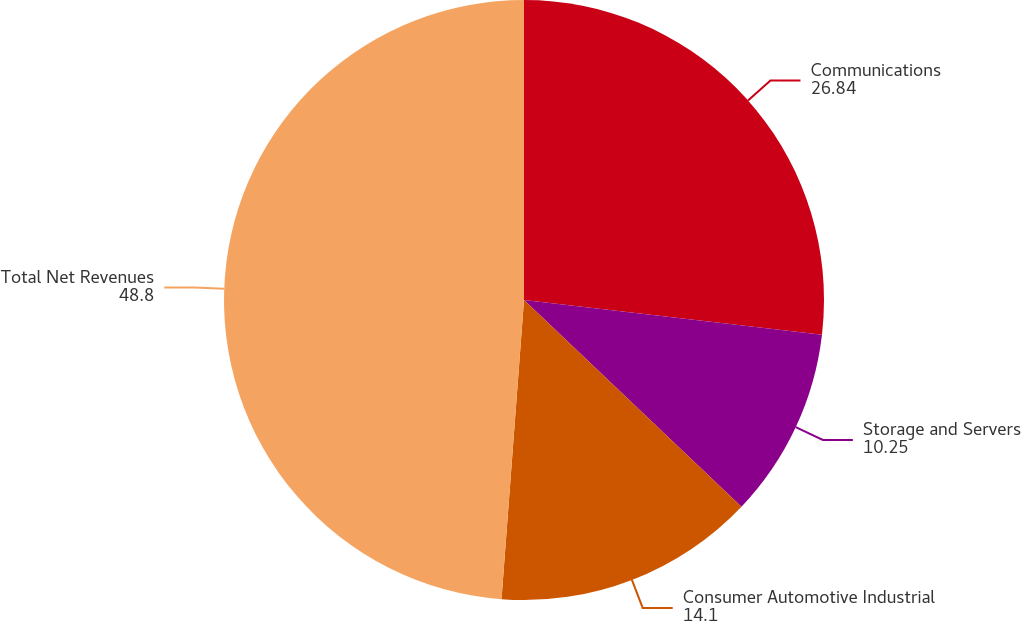<chart> <loc_0><loc_0><loc_500><loc_500><pie_chart><fcel>Communications<fcel>Storage and Servers<fcel>Consumer Automotive Industrial<fcel>Total Net Revenues<nl><fcel>26.84%<fcel>10.25%<fcel>14.1%<fcel>48.8%<nl></chart> 